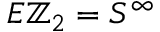<formula> <loc_0><loc_0><loc_500><loc_500>E \mathbb { Z } _ { 2 } = S ^ { \infty }</formula> 